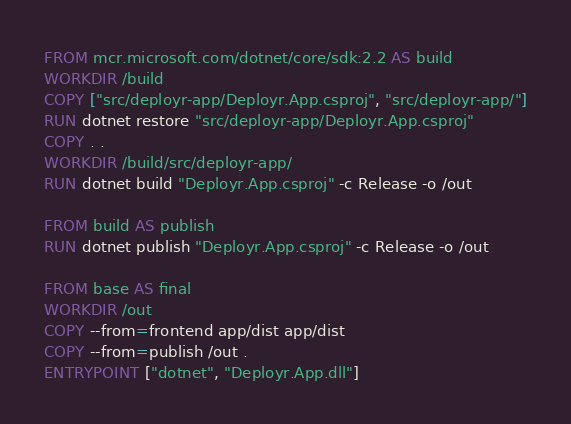<code> <loc_0><loc_0><loc_500><loc_500><_Dockerfile_>
FROM mcr.microsoft.com/dotnet/core/sdk:2.2 AS build
WORKDIR /build
COPY ["src/deployr-app/Deployr.App.csproj", "src/deployr-app/"]
RUN dotnet restore "src/deployr-app/Deployr.App.csproj"
COPY . .
WORKDIR /build/src/deployr-app/
RUN dotnet build "Deployr.App.csproj" -c Release -o /out

FROM build AS publish
RUN dotnet publish "Deployr.App.csproj" -c Release -o /out

FROM base AS final
WORKDIR /out
COPY --from=frontend app/dist app/dist
COPY --from=publish /out .
ENTRYPOINT ["dotnet", "Deployr.App.dll"]</code> 